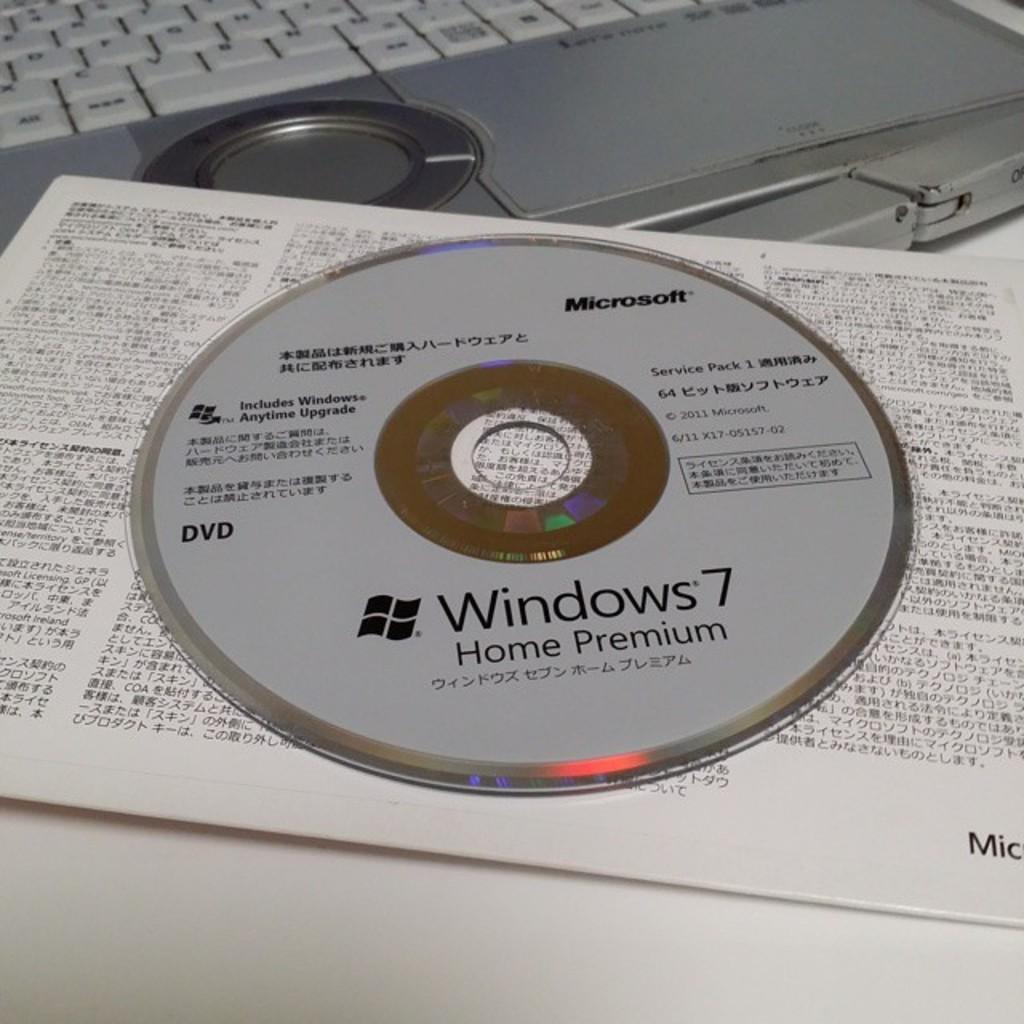Please provide a concise description of this image. In this image I can see a SD, card and laptop keyboard are on the white table. Something is written on the CD and card.   